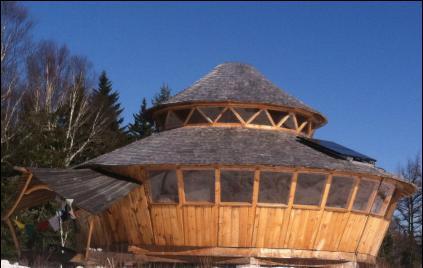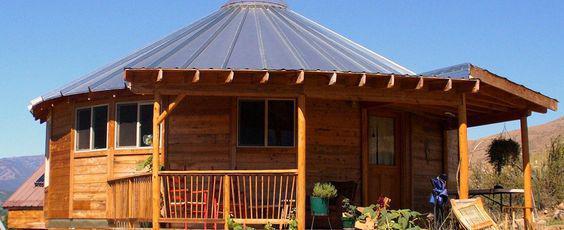The first image is the image on the left, the second image is the image on the right. Considering the images on both sides, is "The exterior of a round building has a covered deck with a railing in front." valid? Answer yes or no. Yes. The first image is the image on the left, the second image is the image on the right. Evaluate the accuracy of this statement regarding the images: "One image is the exterior of a wooden yurt, while the second image is a yurt interior that shows a kitchen area and ribbed wooden ceiling.". Is it true? Answer yes or no. No. 